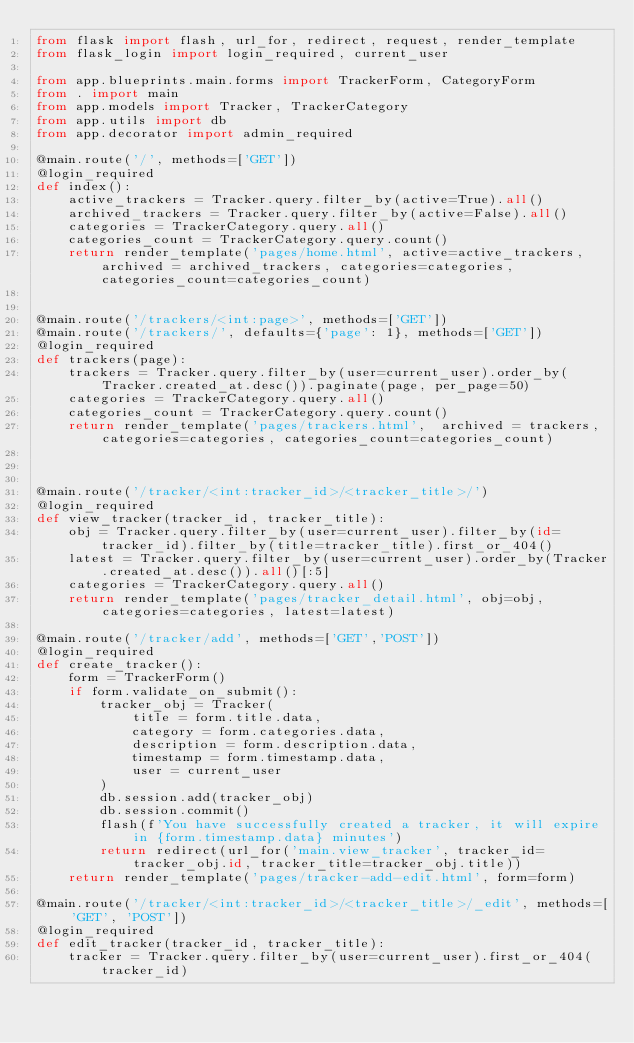<code> <loc_0><loc_0><loc_500><loc_500><_Python_>from flask import flash, url_for, redirect, request, render_template
from flask_login import login_required, current_user

from app.blueprints.main.forms import TrackerForm, CategoryForm
from . import main
from app.models import Tracker, TrackerCategory
from app.utils import db
from app.decorator import admin_required

@main.route('/', methods=['GET'])
@login_required
def index():
    active_trackers = Tracker.query.filter_by(active=True).all()
    archived_trackers = Tracker.query.filter_by(active=False).all()
    categories = TrackerCategory.query.all()
    categories_count = TrackerCategory.query.count()
    return render_template('pages/home.html', active=active_trackers, archived = archived_trackers, categories=categories, categories_count=categories_count)


@main.route('/trackers/<int:page>', methods=['GET'])
@main.route('/trackers/', defaults={'page': 1}, methods=['GET'])
@login_required
def trackers(page):    
    trackers = Tracker.query.filter_by(user=current_user).order_by(Tracker.created_at.desc()).paginate(page, per_page=50)
    categories = TrackerCategory.query.all()
    categories_count = TrackerCategory.query.count()
    return render_template('pages/trackers.html',  archived = trackers, categories=categories, categories_count=categories_count)



@main.route('/tracker/<int:tracker_id>/<tracker_title>/')
@login_required
def view_tracker(tracker_id, tracker_title):
    obj = Tracker.query.filter_by(user=current_user).filter_by(id=tracker_id).filter_by(title=tracker_title).first_or_404()
    latest = Tracker.query.filter_by(user=current_user).order_by(Tracker.created_at.desc()).all()[:5]
    categories = TrackerCategory.query.all()
    return render_template('pages/tracker_detail.html', obj=obj, categories=categories, latest=latest)    

@main.route('/tracker/add', methods=['GET','POST'])
@login_required
def create_tracker():
    form = TrackerForm()
    if form.validate_on_submit():
        tracker_obj = Tracker(
            title = form.title.data,
            category = form.categories.data,
            description = form.description.data,
            timestamp = form.timestamp.data,
            user = current_user
        )
        db.session.add(tracker_obj)
        db.session.commit()
        flash(f'You have successfully created a tracker, it will expire in {form.timestamp.data} minutes')
        return redirect(url_for('main.view_tracker', tracker_id=tracker_obj.id, tracker_title=tracker_obj.title))
    return render_template('pages/tracker-add-edit.html', form=form) 

@main.route('/tracker/<int:tracker_id>/<tracker_title>/_edit', methods=['GET', 'POST'])
@login_required
def edit_tracker(tracker_id, tracker_title):
    tracker = Tracker.query.filter_by(user=current_user).first_or_404(tracker_id)</code> 